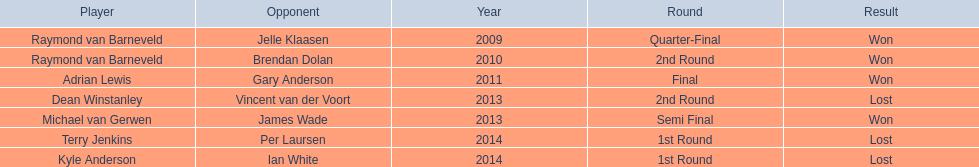What players competed in the pdc world darts championship? Raymond van Barneveld, Raymond van Barneveld, Adrian Lewis, Dean Winstanley, Michael van Gerwen, Terry Jenkins, Kyle Anderson. Of these players, who lost? Dean Winstanley, Terry Jenkins, Kyle Anderson. Which of these players lost in 2014? Terry Jenkins, Kyle Anderson. What are the players other than kyle anderson? Terry Jenkins. 